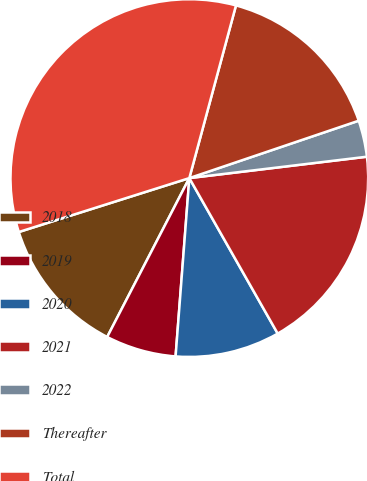Convert chart. <chart><loc_0><loc_0><loc_500><loc_500><pie_chart><fcel>2018<fcel>2019<fcel>2020<fcel>2021<fcel>2022<fcel>Thereafter<fcel>Total<nl><fcel>12.53%<fcel>6.37%<fcel>9.45%<fcel>18.68%<fcel>3.29%<fcel>15.6%<fcel>34.07%<nl></chart> 